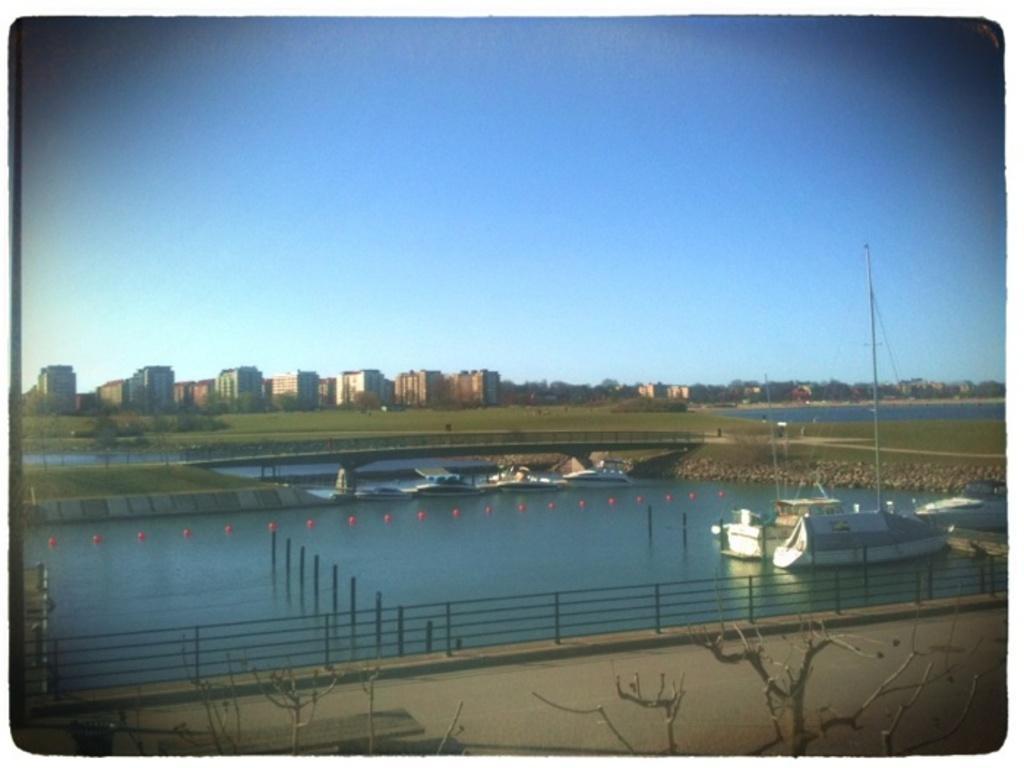In one or two sentences, can you explain what this image depicts? In this picture we can see boats on water, poles, fence, path, trees and in the background we can see buildings, sky. 